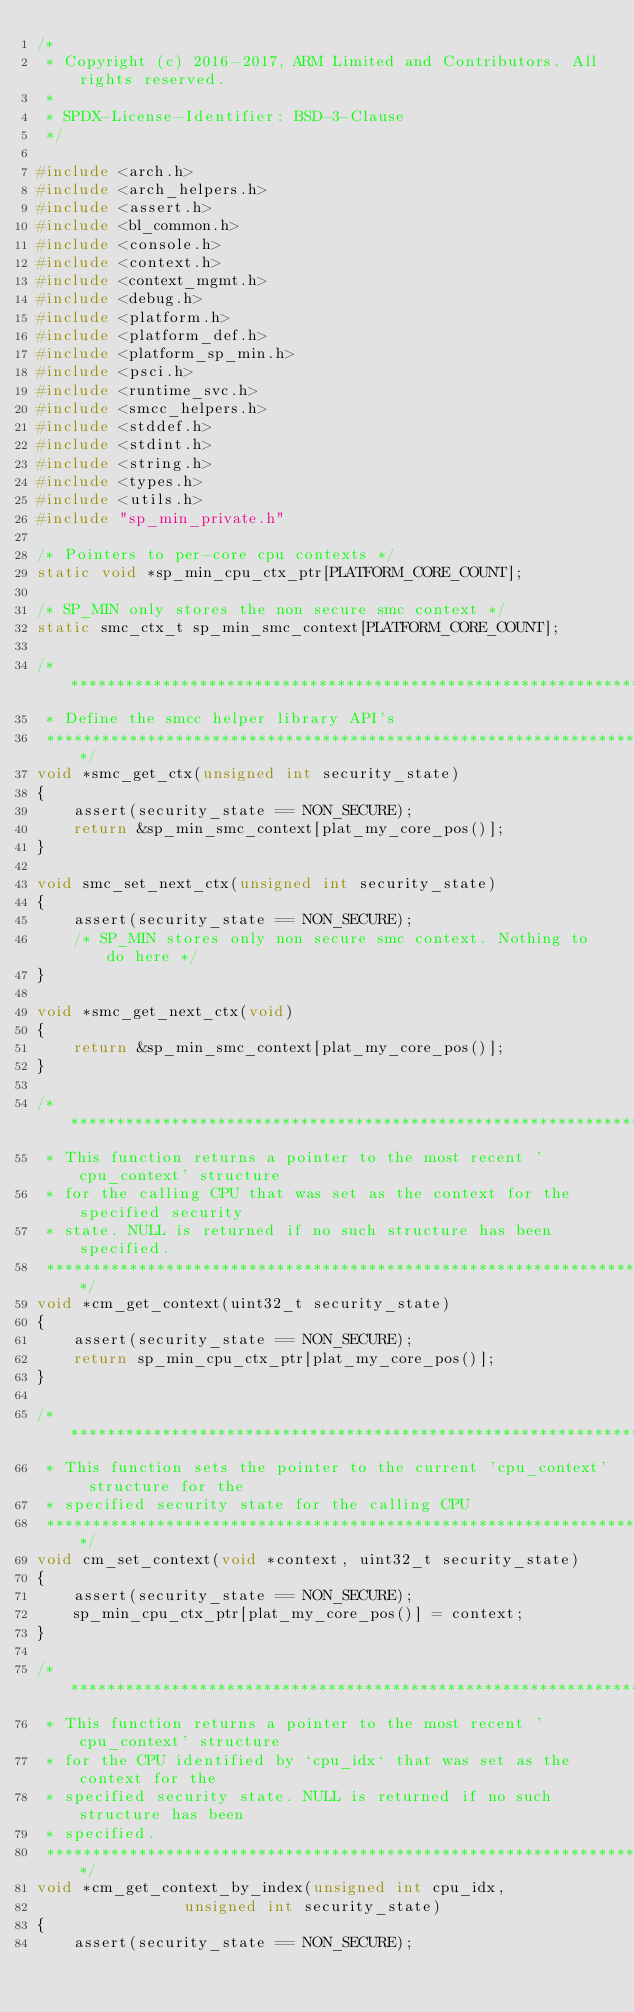Convert code to text. <code><loc_0><loc_0><loc_500><loc_500><_C_>/*
 * Copyright (c) 2016-2017, ARM Limited and Contributors. All rights reserved.
 *
 * SPDX-License-Identifier: BSD-3-Clause
 */

#include <arch.h>
#include <arch_helpers.h>
#include <assert.h>
#include <bl_common.h>
#include <console.h>
#include <context.h>
#include <context_mgmt.h>
#include <debug.h>
#include <platform.h>
#include <platform_def.h>
#include <platform_sp_min.h>
#include <psci.h>
#include <runtime_svc.h>
#include <smcc_helpers.h>
#include <stddef.h>
#include <stdint.h>
#include <string.h>
#include <types.h>
#include <utils.h>
#include "sp_min_private.h"

/* Pointers to per-core cpu contexts */
static void *sp_min_cpu_ctx_ptr[PLATFORM_CORE_COUNT];

/* SP_MIN only stores the non secure smc context */
static smc_ctx_t sp_min_smc_context[PLATFORM_CORE_COUNT];

/******************************************************************************
 * Define the smcc helper library API's
 *****************************************************************************/
void *smc_get_ctx(unsigned int security_state)
{
	assert(security_state == NON_SECURE);
	return &sp_min_smc_context[plat_my_core_pos()];
}

void smc_set_next_ctx(unsigned int security_state)
{
	assert(security_state == NON_SECURE);
	/* SP_MIN stores only non secure smc context. Nothing to do here */
}

void *smc_get_next_ctx(void)
{
	return &sp_min_smc_context[plat_my_core_pos()];
}

/*******************************************************************************
 * This function returns a pointer to the most recent 'cpu_context' structure
 * for the calling CPU that was set as the context for the specified security
 * state. NULL is returned if no such structure has been specified.
 ******************************************************************************/
void *cm_get_context(uint32_t security_state)
{
	assert(security_state == NON_SECURE);
	return sp_min_cpu_ctx_ptr[plat_my_core_pos()];
}

/*******************************************************************************
 * This function sets the pointer to the current 'cpu_context' structure for the
 * specified security state for the calling CPU
 ******************************************************************************/
void cm_set_context(void *context, uint32_t security_state)
{
	assert(security_state == NON_SECURE);
	sp_min_cpu_ctx_ptr[plat_my_core_pos()] = context;
}

/*******************************************************************************
 * This function returns a pointer to the most recent 'cpu_context' structure
 * for the CPU identified by `cpu_idx` that was set as the context for the
 * specified security state. NULL is returned if no such structure has been
 * specified.
 ******************************************************************************/
void *cm_get_context_by_index(unsigned int cpu_idx,
				unsigned int security_state)
{
	assert(security_state == NON_SECURE);</code> 